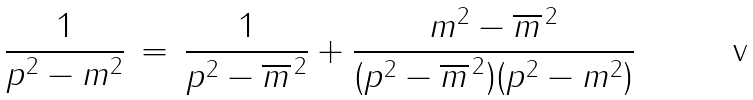Convert formula to latex. <formula><loc_0><loc_0><loc_500><loc_500>\frac { 1 } { p ^ { 2 } - m ^ { 2 } } \, = \, \frac { 1 } { p ^ { 2 } - \overline { m } ^ { \, 2 } } + \frac { m ^ { 2 } - \overline { m } ^ { \, 2 } } { ( p ^ { 2 } - \overline { m } ^ { \, 2 } ) ( p ^ { 2 } - m ^ { 2 } ) }</formula> 